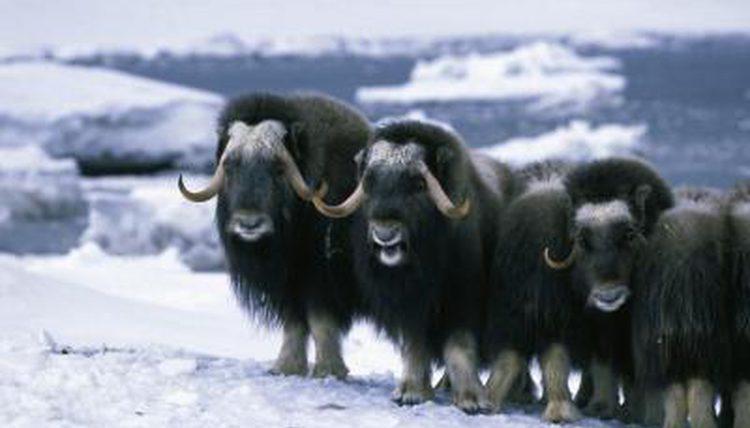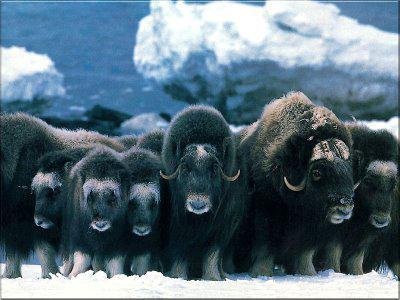The first image is the image on the left, the second image is the image on the right. Evaluate the accuracy of this statement regarding the images: "At least one image shows a group of buffalo-type animals standing on non-snowy ground.". Is it true? Answer yes or no. No. 